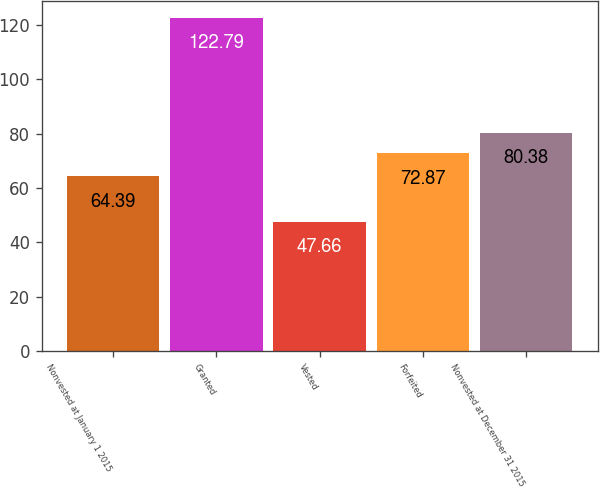<chart> <loc_0><loc_0><loc_500><loc_500><bar_chart><fcel>Nonvested at January 1 2015<fcel>Granted<fcel>Vested<fcel>Forfeited<fcel>Nonvested at December 31 2015<nl><fcel>64.39<fcel>122.79<fcel>47.66<fcel>72.87<fcel>80.38<nl></chart> 